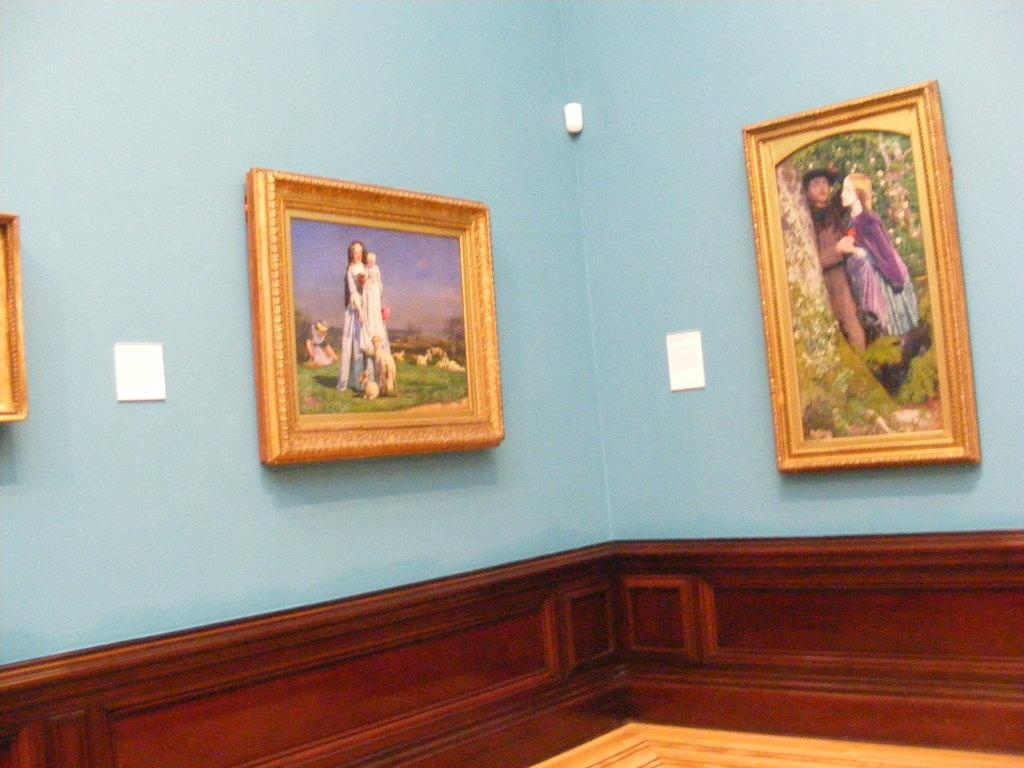What type of location is shown in the image? The image depicts an inside view of a room. What can be seen on the walls of the room? There are frames on the wall in the room. What type of toys can be seen on the floor in the image? There are no toys visible on the floor in the image. 